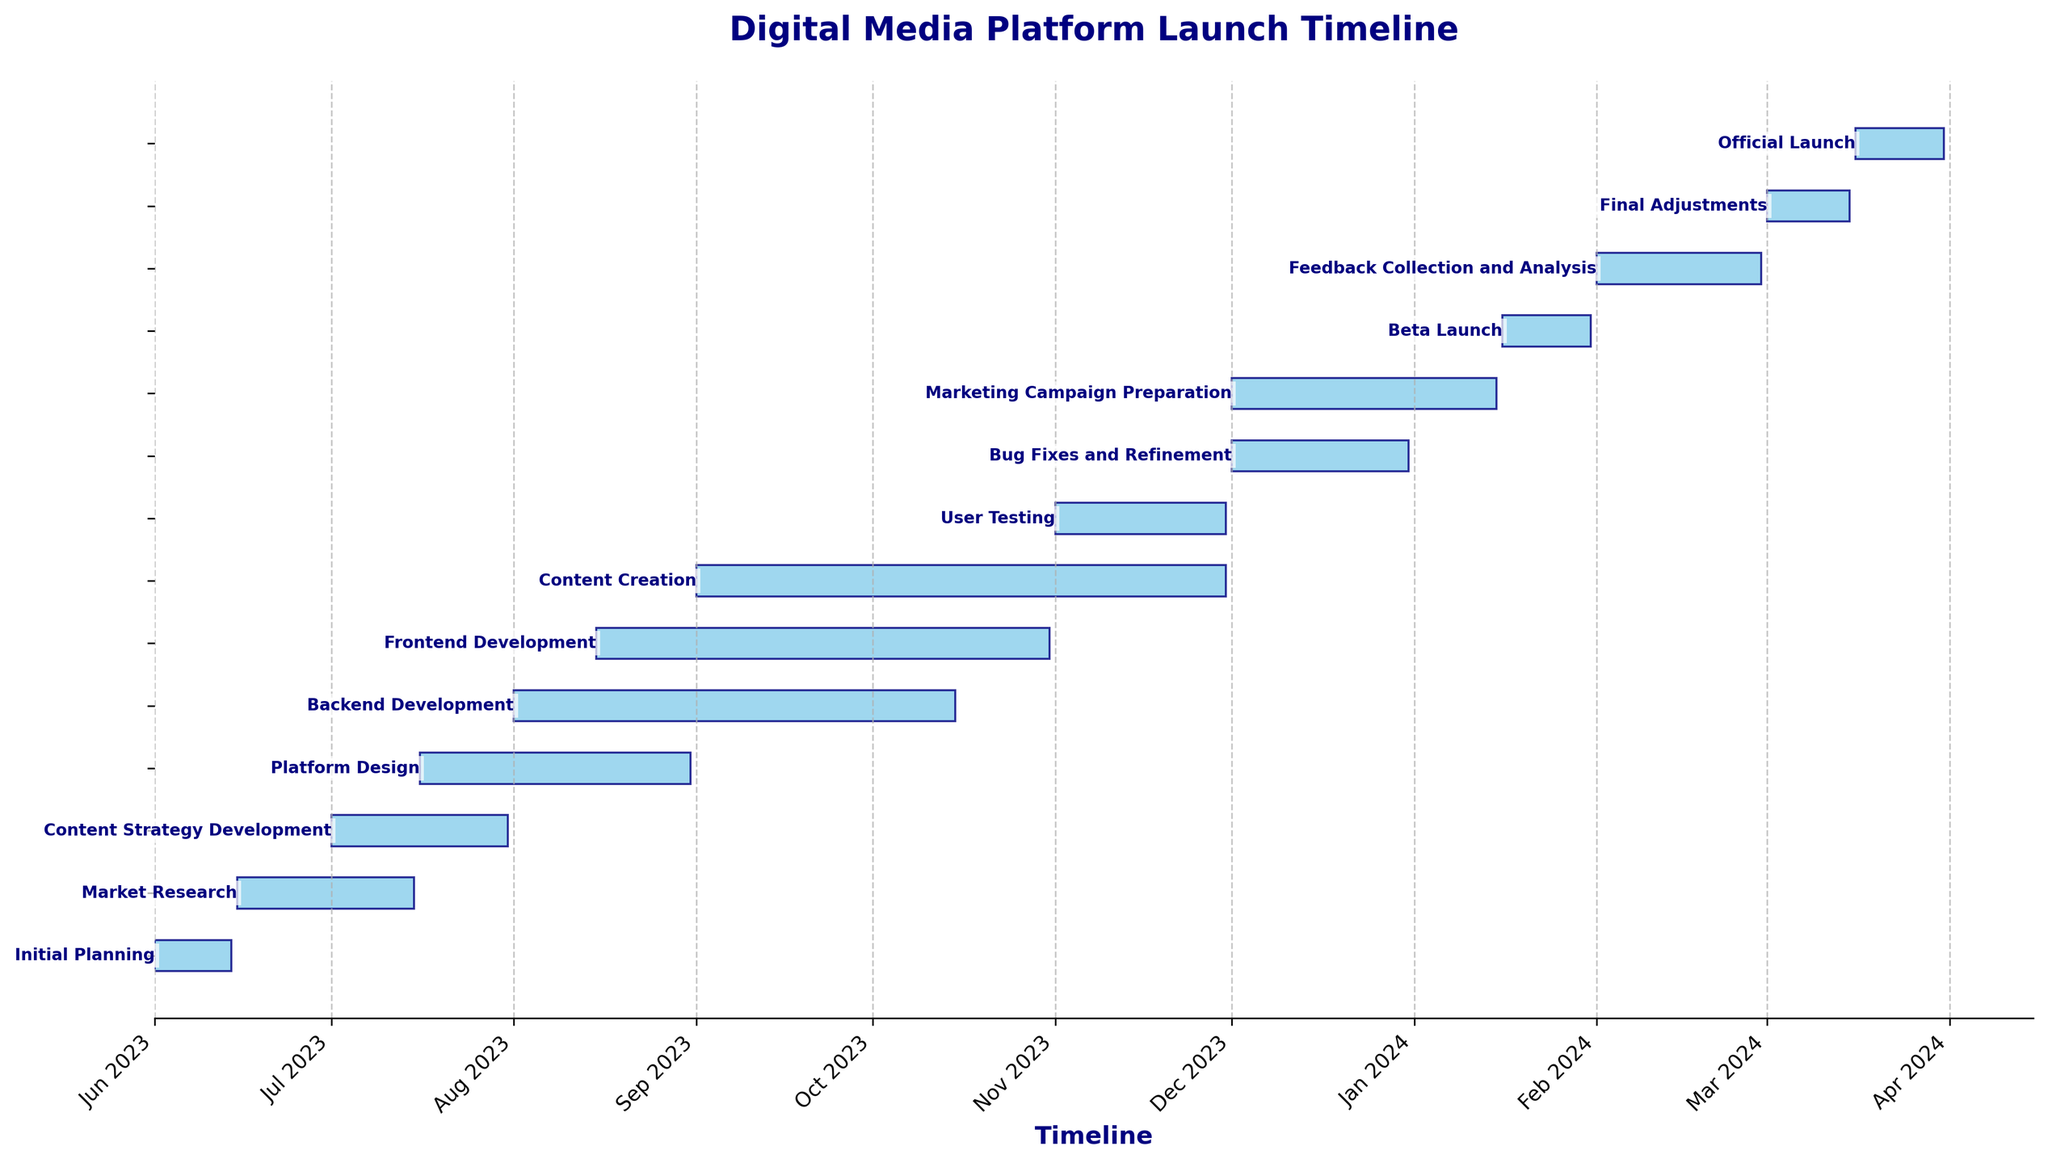Which task has the shortest duration? To identify the shortest task, look for the task with the smallest bar length. The bar labeled 'Beta Launch' has the shortest duration.
Answer: Beta Launch Which tasks are overlapping during November 2023? To find overlapping tasks, check for bars spanning the period of November 2023. The 'Content Creation', 'User Testing', and 'Backend Development' tasks overlap during this time.
Answer: Content Creation, User Testing, Backend Development What is the duration of the Market Research task? The 'Market Research' task starts on June 15, 2023, and ends on July 15, 2023. The duration is (July 15 - June 15) which is 31 days.
Answer: 31 days How many days after the Backend Development starts does the Frontend Development start? The 'Backend Development' starts on August 1, 2023, and the 'Frontend Development' starts on August 15, 2023. The difference in days is (August 15 - August 1) which is 14 days.
Answer: 14 days Which tasks are still ongoing when Content Creation begins? To determine this, check which tasks overlap with the start date of 'Content Creation', which is September 1, 2023. 'Backend Development' and 'Frontend Development' are ongoing during this time.
Answer: Backend Development, Frontend Development Across how many months does the Platform Design span? 'Platform Design' starts on July 16, 2023, and ends on August 31, 2023. It spans parts of July and the whole of August, so it spans two months.
Answer: 2 months Which task ends right before the Official Launch? The 'Final Adjustments' task ends on March 15, 2024, and the 'Official Launch' starts immediately after on March 16, 2024. Therefore, 'Final Adjustments' ends right before the 'Official Launch'.
Answer: Final Adjustments What is the total duration (in days) of all tasks combined? Add up the individual durations of all tasks: 14 + 31 + 31 + 47 + 76 + 78 + 91 + 30 + 31 + 46 + 16 + 29 + 15 + 16. Calculating this sum results in 551 days.
Answer: 551 days Which task takes longer: Backend Development or Frontend Development? The 'Backend Development' task has a duration of 76 days, while the 'Frontend Development' task has a duration of 78 days. Comparing these, the 'Frontend Development' task takes longer.
Answer: Frontend Development 